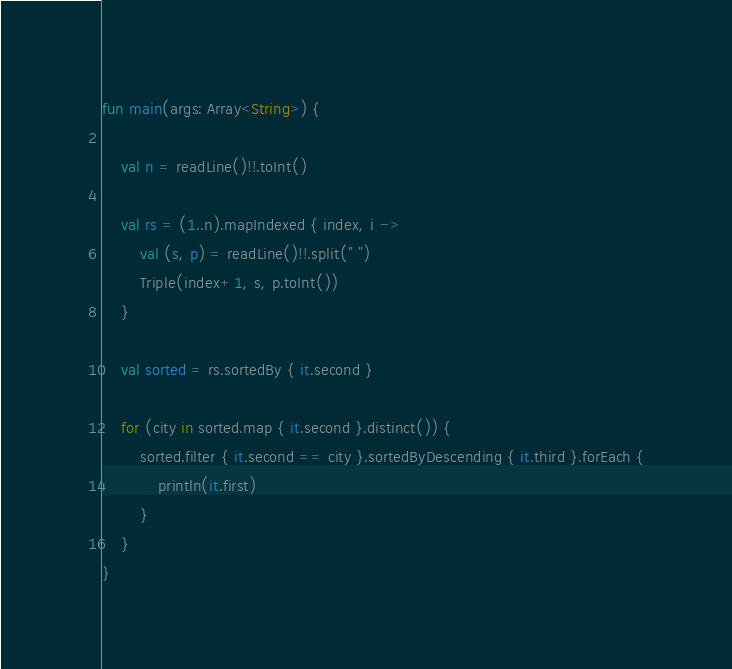Convert code to text. <code><loc_0><loc_0><loc_500><loc_500><_Kotlin_>fun main(args: Array<String>) {

    val n = readLine()!!.toInt()

    val rs = (1..n).mapIndexed { index, i ->
        val (s, p) = readLine()!!.split(" ")
        Triple(index+1, s, p.toInt())
    }

    val sorted = rs.sortedBy { it.second }

    for (city in sorted.map { it.second }.distinct()) {
        sorted.filter { it.second == city }.sortedByDescending { it.third }.forEach {
            println(it.first)
        }
    }
}</code> 